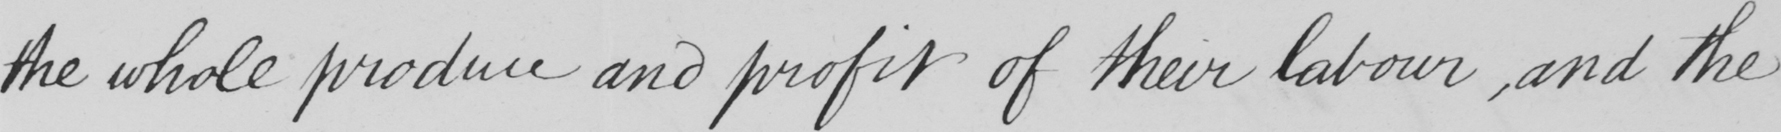Can you tell me what this handwritten text says? the whole produce and profit of their labour, and the 